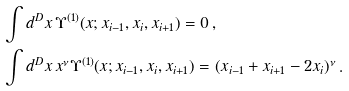<formula> <loc_0><loc_0><loc_500><loc_500>& \int d ^ { D } x \, \Upsilon ^ { ( 1 ) } ( x ; x _ { i - 1 } , x _ { i } , x _ { i + 1 } ) = 0 \, , \\ & \int d ^ { D } x \, x ^ { \nu } \Upsilon ^ { ( 1 ) } ( x ; x _ { i - 1 } , x _ { i } , x _ { i + 1 } ) = ( x _ { i - 1 } + x _ { i + 1 } - 2 x _ { i } ) ^ { \nu } \, .</formula> 